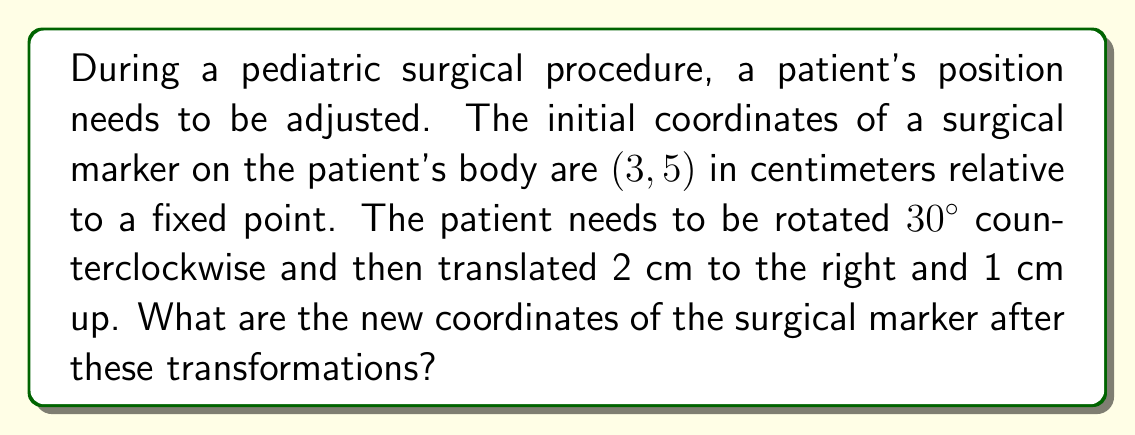Solve this math problem. To solve this problem, we'll follow these steps:

1) First, we need to rotate the point $(3, 5)$ by 30° counterclockwise. The rotation matrix for a counterclockwise rotation by angle $\theta$ is:

   $$\begin{pmatrix} \cos\theta & -\sin\theta \\ \sin\theta & \cos\theta \end{pmatrix}$$

   For 30°, we have:

   $$\begin{pmatrix} \cos30° & -\sin30° \\ \sin30° & \cos30° \end{pmatrix} = \begin{pmatrix} \frac{\sqrt{3}}{2} & -\frac{1}{2} \\ \frac{1}{2} & \frac{\sqrt{3}}{2} \end{pmatrix}$$

2) We apply this rotation to our point:

   $$\begin{pmatrix} \frac{\sqrt{3}}{2} & -\frac{1}{2} \\ \frac{1}{2} & \frac{\sqrt{3}}{2} \end{pmatrix} \begin{pmatrix} 3 \\ 5 \end{pmatrix} = \begin{pmatrix} \frac{3\sqrt{3}}{2} - \frac{5}{2} \\ \frac{3}{2} + \frac{5\sqrt{3}}{2} \end{pmatrix}$$

3) Simplify:
   
   $x' = \frac{3\sqrt{3}}{2} - \frac{5}{2} \approx 1.0981$
   $y' = \frac{3}{2} + \frac{5\sqrt{3}}{2} \approx 5.8301$

4) Now, we need to translate this point 2 cm to the right and 1 cm up. This means adding 2 to the x-coordinate and 1 to the y-coordinate:

   $x'' = x' + 2 = \frac{3\sqrt{3}}{2} - \frac{5}{2} + 2 = \frac{3\sqrt{3}}{2} - \frac{1}{2} \approx 3.0981$
   $y'' = y' + 1 = \frac{3}{2} + \frac{5\sqrt{3}}{2} + 1 = \frac{5}{2} + \frac{5\sqrt{3}}{2} \approx 6.8301$

5) Therefore, the new coordinates after rotation and translation are $(\frac{3\sqrt{3}}{2} - \frac{1}{2}, \frac{5}{2} + \frac{5\sqrt{3}}{2})$ or approximately $(3.0981, 6.8301)$ cm.
Answer: $(\frac{3\sqrt{3}}{2} - \frac{1}{2}, \frac{5}{2} + \frac{5\sqrt{3}}{2})$ or approximately $(3.10, 6.83)$ cm 